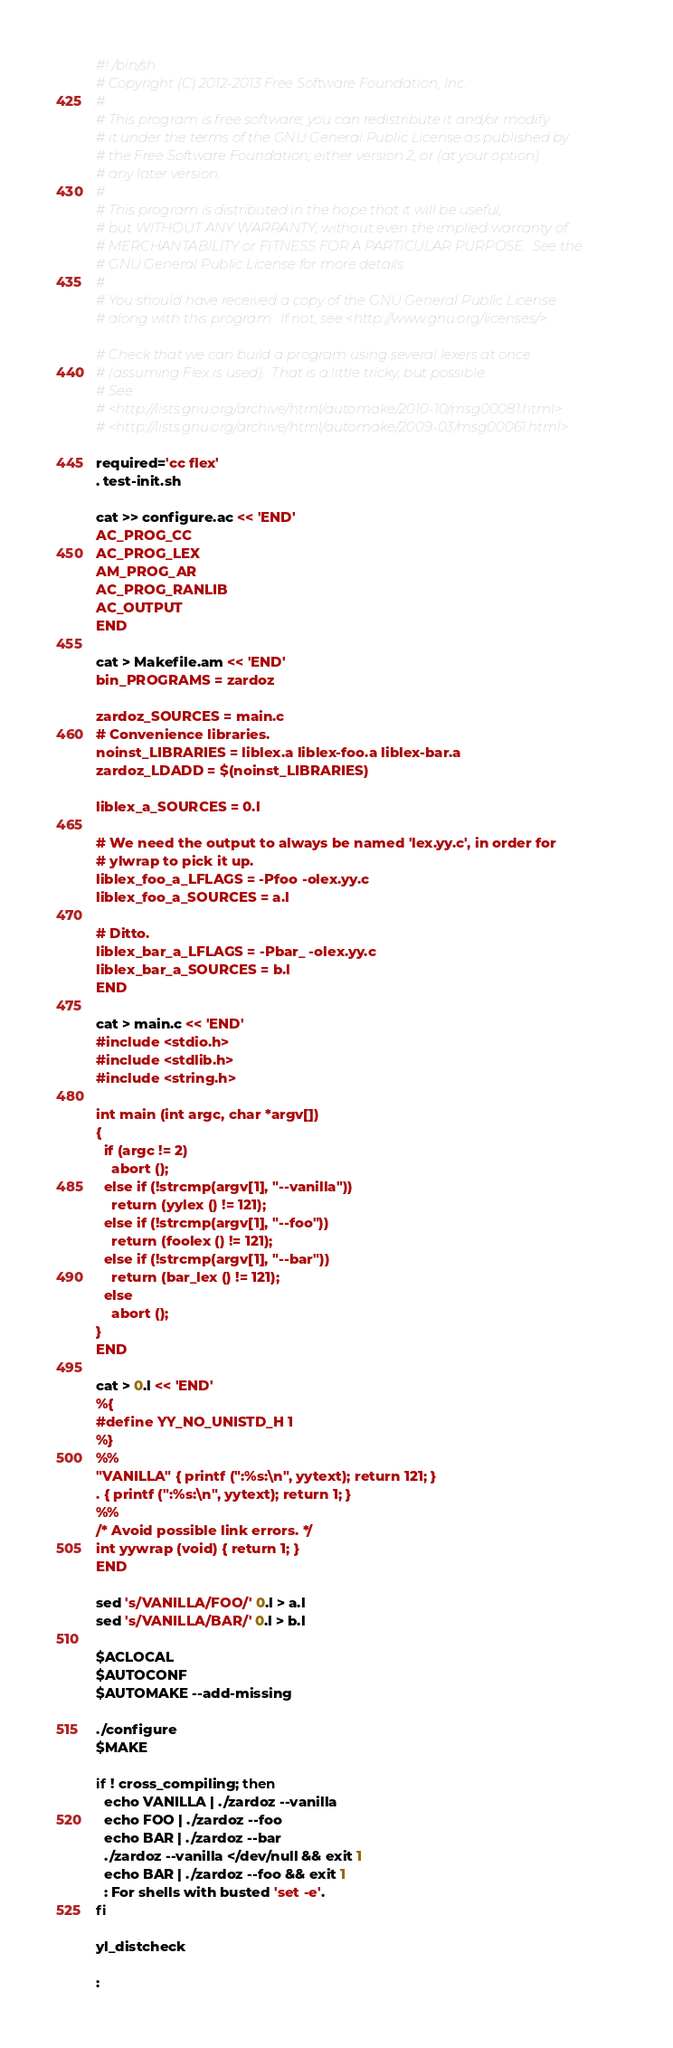Convert code to text. <code><loc_0><loc_0><loc_500><loc_500><_Bash_>#! /bin/sh
# Copyright (C) 2012-2013 Free Software Foundation, Inc.
#
# This program is free software; you can redistribute it and/or modify
# it under the terms of the GNU General Public License as published by
# the Free Software Foundation; either version 2, or (at your option)
# any later version.
#
# This program is distributed in the hope that it will be useful,
# but WITHOUT ANY WARRANTY; without even the implied warranty of
# MERCHANTABILITY or FITNESS FOR A PARTICULAR PURPOSE.  See the
# GNU General Public License for more details.
#
# You should have received a copy of the GNU General Public License
# along with this program.  If not, see <http://www.gnu.org/licenses/>.

# Check that we can build a program using several lexers at once
# (assuming Flex is used).  That is a little tricky, but possible.
# See:
# <http://lists.gnu.org/archive/html/automake/2010-10/msg00081.html>
# <http://lists.gnu.org/archive/html/automake/2009-03/msg00061.html>

required='cc flex'
. test-init.sh

cat >> configure.ac << 'END'
AC_PROG_CC
AC_PROG_LEX
AM_PROG_AR
AC_PROG_RANLIB
AC_OUTPUT
END

cat > Makefile.am << 'END'
bin_PROGRAMS = zardoz

zardoz_SOURCES = main.c
# Convenience libraries.
noinst_LIBRARIES = liblex.a liblex-foo.a liblex-bar.a
zardoz_LDADD = $(noinst_LIBRARIES)

liblex_a_SOURCES = 0.l

# We need the output to always be named 'lex.yy.c', in order for
# ylwrap to pick it up.
liblex_foo_a_LFLAGS = -Pfoo -olex.yy.c
liblex_foo_a_SOURCES = a.l

# Ditto.
liblex_bar_a_LFLAGS = -Pbar_ -olex.yy.c
liblex_bar_a_SOURCES = b.l
END

cat > main.c << 'END'
#include <stdio.h>
#include <stdlib.h>
#include <string.h>

int main (int argc, char *argv[])
{
  if (argc != 2)
    abort ();
  else if (!strcmp(argv[1], "--vanilla"))
    return (yylex () != 121);
  else if (!strcmp(argv[1], "--foo"))
    return (foolex () != 121);
  else if (!strcmp(argv[1], "--bar"))
    return (bar_lex () != 121);
  else
    abort ();
}
END

cat > 0.l << 'END'
%{
#define YY_NO_UNISTD_H 1
%}
%%
"VANILLA" { printf (":%s:\n", yytext); return 121; }
. { printf (":%s:\n", yytext); return 1; }
%%
/* Avoid possible link errors. */
int yywrap (void) { return 1; }
END

sed 's/VANILLA/FOO/' 0.l > a.l
sed 's/VANILLA/BAR/' 0.l > b.l

$ACLOCAL
$AUTOCONF
$AUTOMAKE --add-missing

./configure
$MAKE

if ! cross_compiling; then
  echo VANILLA | ./zardoz --vanilla
  echo FOO | ./zardoz --foo
  echo BAR | ./zardoz --bar
  ./zardoz --vanilla </dev/null && exit 1
  echo BAR | ./zardoz --foo && exit 1
  : For shells with busted 'set -e'.
fi

yl_distcheck

:
</code> 